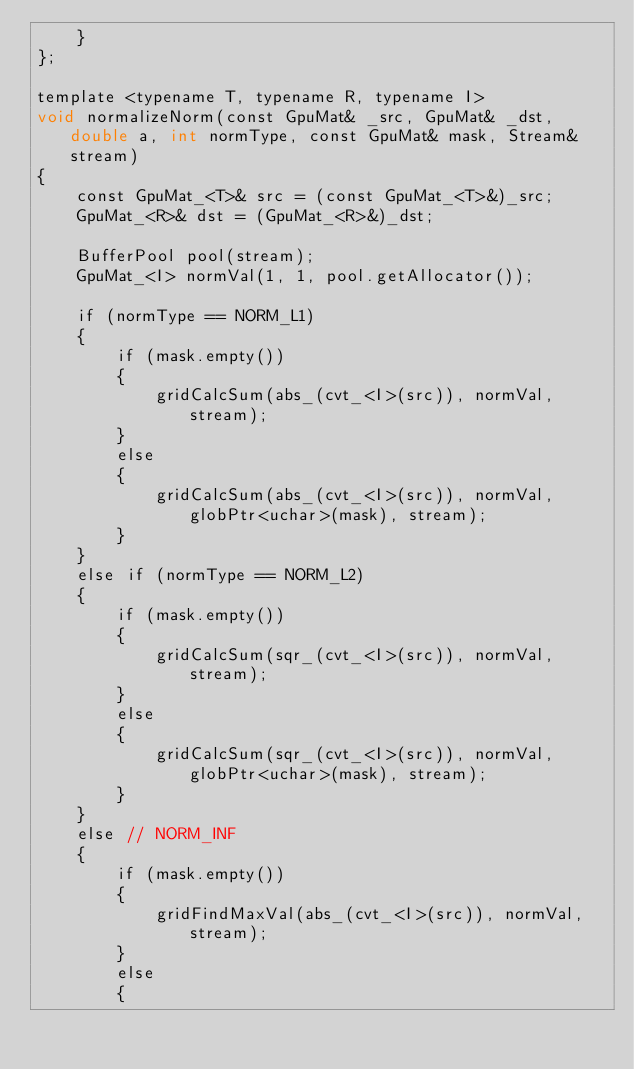<code> <loc_0><loc_0><loc_500><loc_500><_Cuda_>    }
};

template <typename T, typename R, typename I>
void normalizeNorm(const GpuMat& _src, GpuMat& _dst, double a, int normType, const GpuMat& mask, Stream& stream)
{
    const GpuMat_<T>& src = (const GpuMat_<T>&)_src;
    GpuMat_<R>& dst = (GpuMat_<R>&)_dst;

    BufferPool pool(stream);
    GpuMat_<I> normVal(1, 1, pool.getAllocator());

    if (normType == NORM_L1)
    {
        if (mask.empty())
        {
            gridCalcSum(abs_(cvt_<I>(src)), normVal, stream);
        }
        else
        {
            gridCalcSum(abs_(cvt_<I>(src)), normVal, globPtr<uchar>(mask), stream);
        }
    }
    else if (normType == NORM_L2)
    {
        if (mask.empty())
        {
            gridCalcSum(sqr_(cvt_<I>(src)), normVal, stream);
        }
        else
        {
            gridCalcSum(sqr_(cvt_<I>(src)), normVal, globPtr<uchar>(mask), stream);
        }
    }
    else // NORM_INF
    {
        if (mask.empty())
        {
            gridFindMaxVal(abs_(cvt_<I>(src)), normVal, stream);
        }
        else
        {</code> 